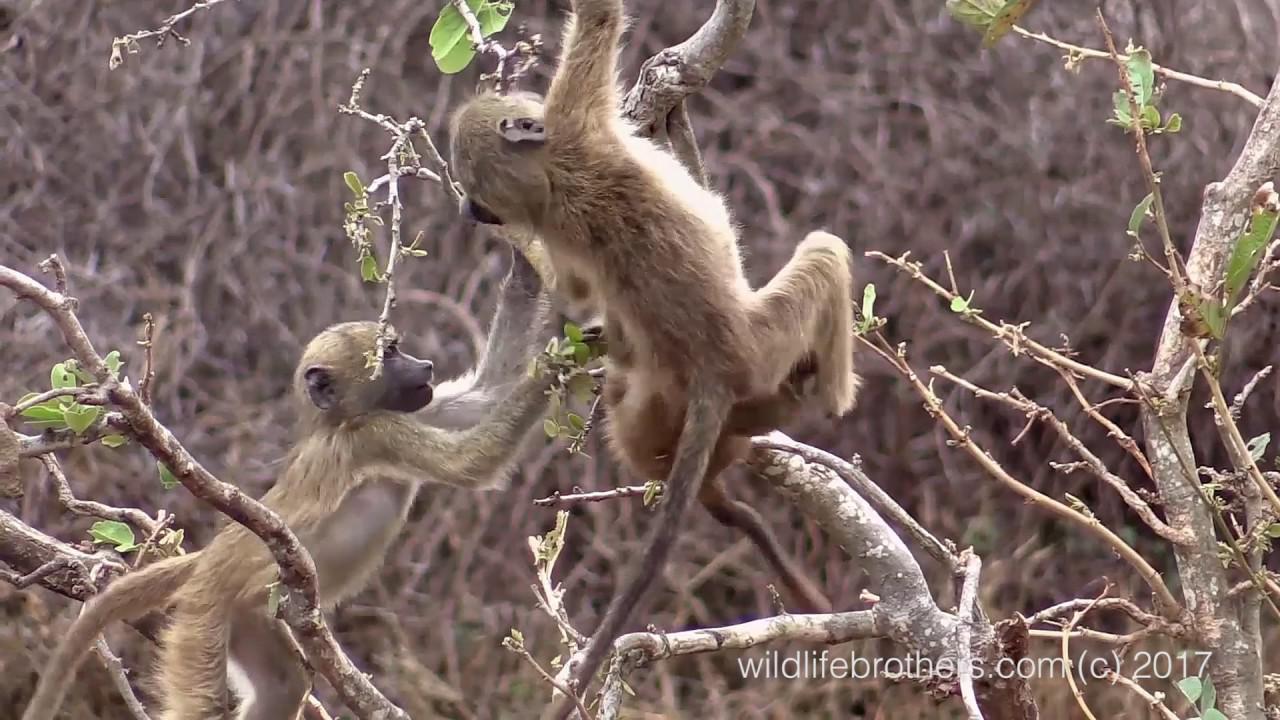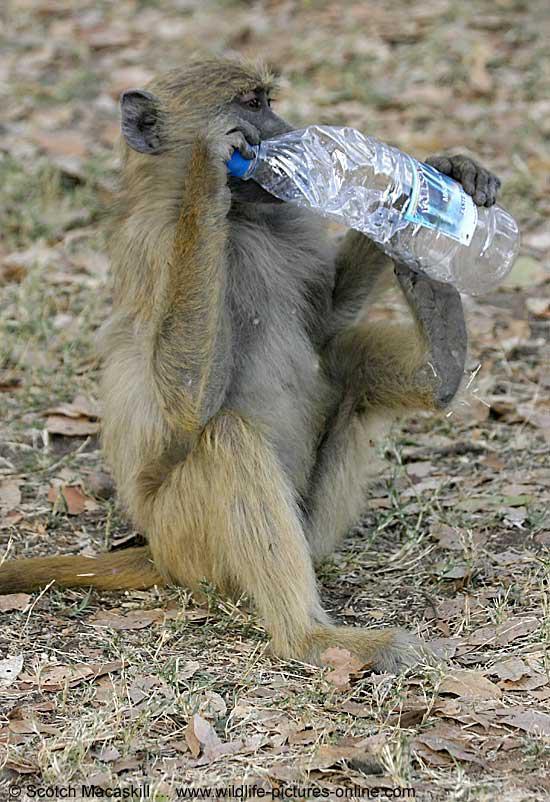The first image is the image on the left, the second image is the image on the right. Considering the images on both sides, is "There are no more than four monkeys." valid? Answer yes or no. Yes. The first image is the image on the left, the second image is the image on the right. Analyze the images presented: Is the assertion "In one of the images monkeys are in a tree." valid? Answer yes or no. Yes. 